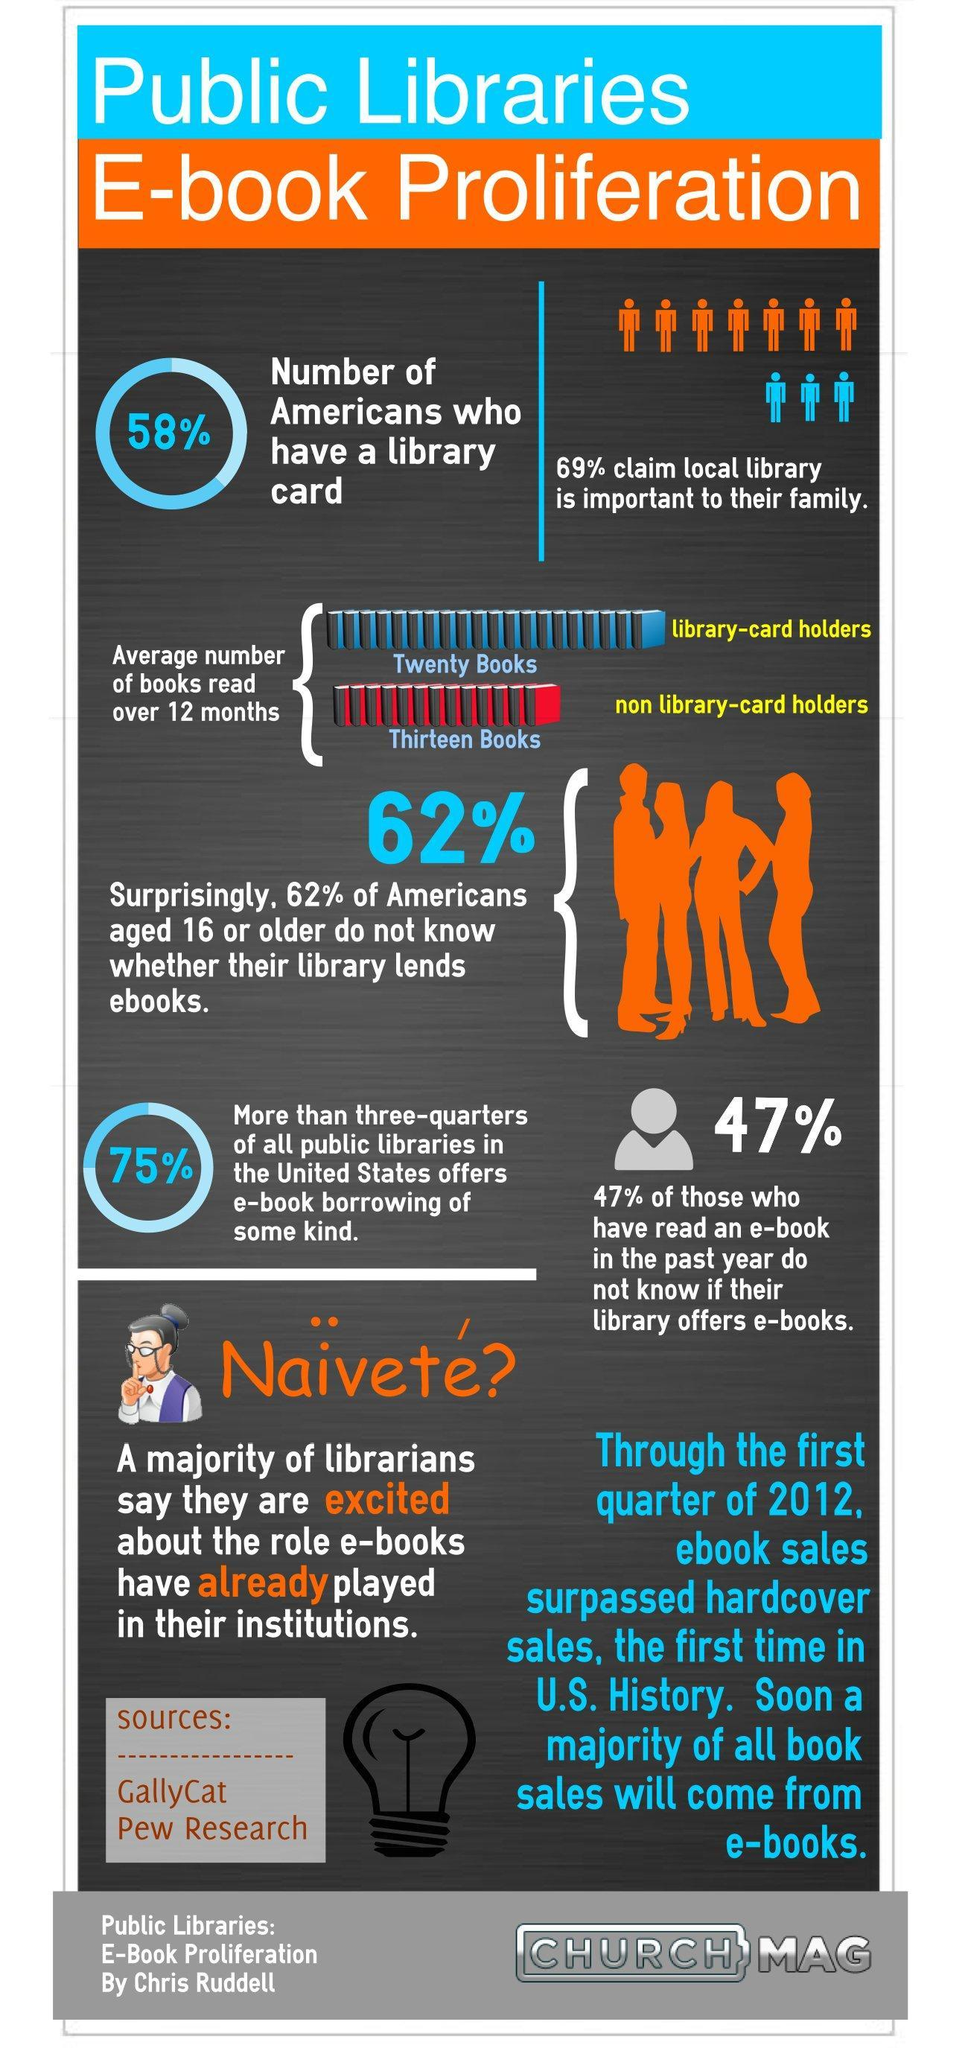What percentage of Americans do not have a library card?
Answer the question with a short phrase. 42% 